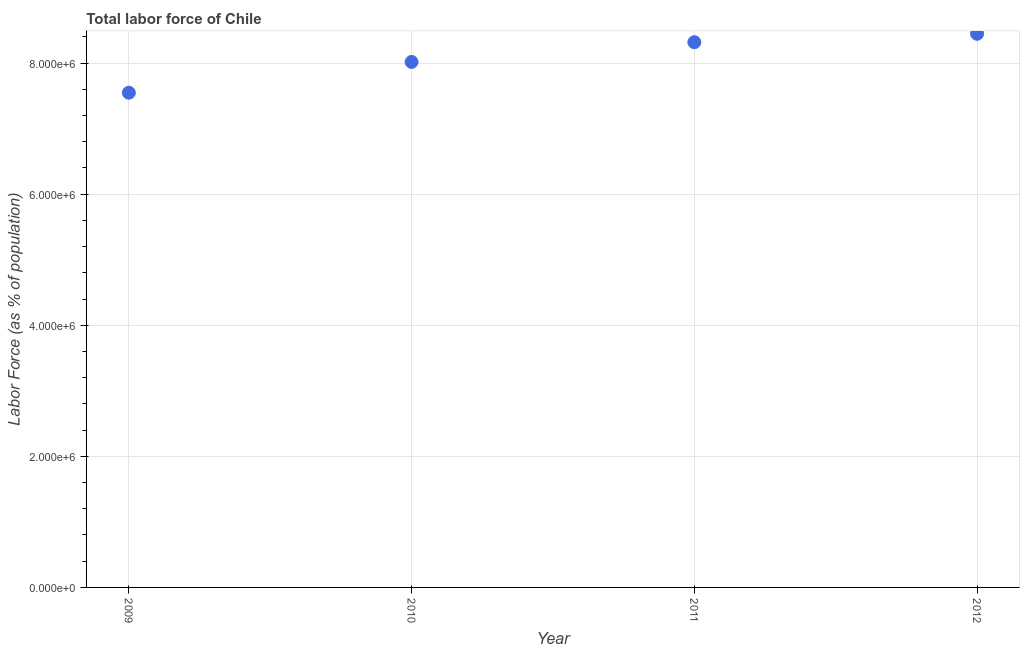What is the total labor force in 2011?
Provide a short and direct response. 8.32e+06. Across all years, what is the maximum total labor force?
Offer a very short reply. 8.45e+06. Across all years, what is the minimum total labor force?
Offer a very short reply. 7.55e+06. What is the sum of the total labor force?
Your answer should be very brief. 3.23e+07. What is the difference between the total labor force in 2009 and 2011?
Offer a very short reply. -7.71e+05. What is the average total labor force per year?
Provide a short and direct response. 8.08e+06. What is the median total labor force?
Offer a terse response. 8.17e+06. Do a majority of the years between 2009 and 2011 (inclusive) have total labor force greater than 2000000 %?
Provide a succinct answer. Yes. What is the ratio of the total labor force in 2009 to that in 2011?
Your response must be concise. 0.91. Is the total labor force in 2010 less than that in 2012?
Provide a short and direct response. Yes. Is the difference between the total labor force in 2009 and 2012 greater than the difference between any two years?
Keep it short and to the point. Yes. What is the difference between the highest and the second highest total labor force?
Your answer should be very brief. 1.29e+05. What is the difference between the highest and the lowest total labor force?
Provide a succinct answer. 8.99e+05. What is the title of the graph?
Offer a very short reply. Total labor force of Chile. What is the label or title of the Y-axis?
Make the answer very short. Labor Force (as % of population). What is the Labor Force (as % of population) in 2009?
Offer a very short reply. 7.55e+06. What is the Labor Force (as % of population) in 2010?
Provide a succinct answer. 8.02e+06. What is the Labor Force (as % of population) in 2011?
Provide a succinct answer. 8.32e+06. What is the Labor Force (as % of population) in 2012?
Give a very brief answer. 8.45e+06. What is the difference between the Labor Force (as % of population) in 2009 and 2010?
Your response must be concise. -4.70e+05. What is the difference between the Labor Force (as % of population) in 2009 and 2011?
Your answer should be compact. -7.71e+05. What is the difference between the Labor Force (as % of population) in 2009 and 2012?
Provide a short and direct response. -8.99e+05. What is the difference between the Labor Force (as % of population) in 2010 and 2011?
Keep it short and to the point. -3.01e+05. What is the difference between the Labor Force (as % of population) in 2010 and 2012?
Your response must be concise. -4.30e+05. What is the difference between the Labor Force (as % of population) in 2011 and 2012?
Offer a terse response. -1.29e+05. What is the ratio of the Labor Force (as % of population) in 2009 to that in 2010?
Your answer should be very brief. 0.94. What is the ratio of the Labor Force (as % of population) in 2009 to that in 2011?
Offer a terse response. 0.91. What is the ratio of the Labor Force (as % of population) in 2009 to that in 2012?
Your answer should be compact. 0.89. What is the ratio of the Labor Force (as % of population) in 2010 to that in 2012?
Ensure brevity in your answer.  0.95. 